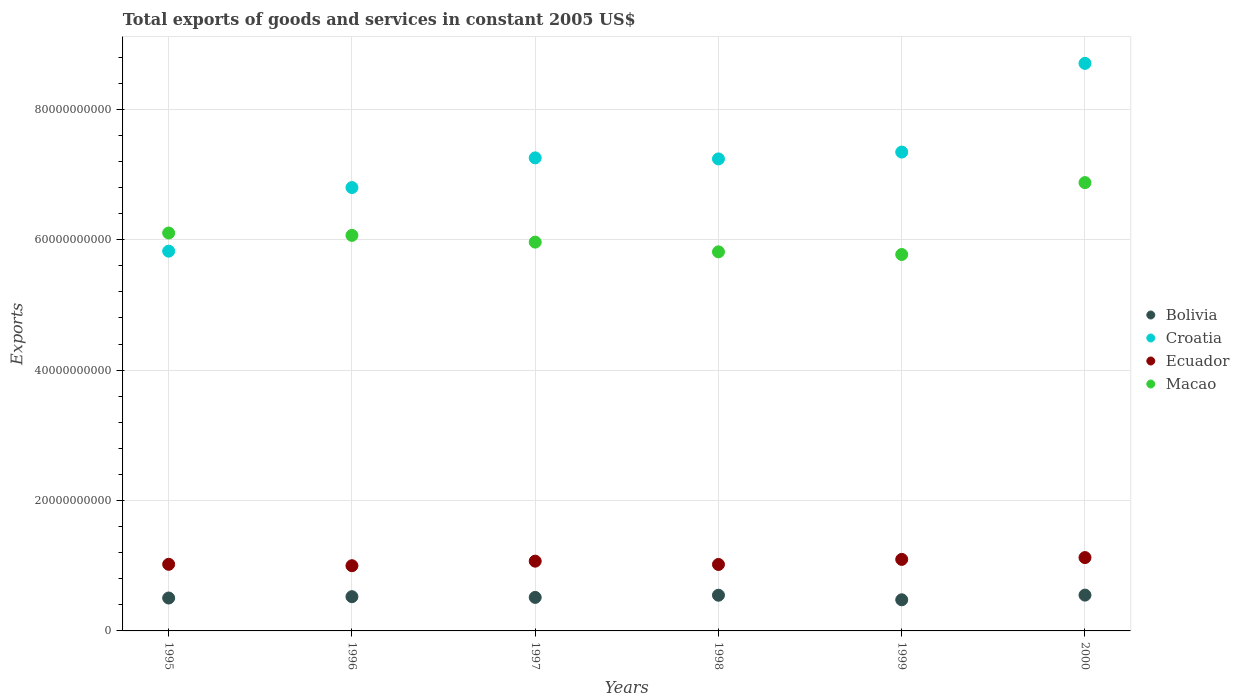How many different coloured dotlines are there?
Your response must be concise. 4. Is the number of dotlines equal to the number of legend labels?
Provide a short and direct response. Yes. What is the total exports of goods and services in Croatia in 1997?
Provide a succinct answer. 7.26e+1. Across all years, what is the maximum total exports of goods and services in Macao?
Your response must be concise. 6.88e+1. Across all years, what is the minimum total exports of goods and services in Bolivia?
Provide a succinct answer. 4.77e+09. In which year was the total exports of goods and services in Croatia minimum?
Your response must be concise. 1995. What is the total total exports of goods and services in Croatia in the graph?
Provide a short and direct response. 4.32e+11. What is the difference between the total exports of goods and services in Bolivia in 1996 and that in 1998?
Keep it short and to the point. -2.22e+08. What is the difference between the total exports of goods and services in Ecuador in 1997 and the total exports of goods and services in Bolivia in 1996?
Provide a succinct answer. 5.45e+09. What is the average total exports of goods and services in Macao per year?
Give a very brief answer. 6.10e+1. In the year 1998, what is the difference between the total exports of goods and services in Croatia and total exports of goods and services in Ecuador?
Your answer should be very brief. 6.22e+1. What is the ratio of the total exports of goods and services in Ecuador in 1996 to that in 1997?
Your answer should be compact. 0.93. Is the total exports of goods and services in Croatia in 1995 less than that in 2000?
Your answer should be very brief. Yes. Is the difference between the total exports of goods and services in Croatia in 1997 and 2000 greater than the difference between the total exports of goods and services in Ecuador in 1997 and 2000?
Keep it short and to the point. No. What is the difference between the highest and the second highest total exports of goods and services in Macao?
Ensure brevity in your answer.  7.73e+09. What is the difference between the highest and the lowest total exports of goods and services in Macao?
Your response must be concise. 1.10e+1. Is it the case that in every year, the sum of the total exports of goods and services in Croatia and total exports of goods and services in Macao  is greater than the sum of total exports of goods and services in Bolivia and total exports of goods and services in Ecuador?
Keep it short and to the point. Yes. Does the total exports of goods and services in Bolivia monotonically increase over the years?
Keep it short and to the point. No. Is the total exports of goods and services in Macao strictly less than the total exports of goods and services in Croatia over the years?
Give a very brief answer. No. How many years are there in the graph?
Give a very brief answer. 6. What is the difference between two consecutive major ticks on the Y-axis?
Provide a short and direct response. 2.00e+1. Are the values on the major ticks of Y-axis written in scientific E-notation?
Your answer should be compact. No. Does the graph contain any zero values?
Provide a succinct answer. No. Does the graph contain grids?
Your answer should be compact. Yes. How are the legend labels stacked?
Provide a succinct answer. Vertical. What is the title of the graph?
Give a very brief answer. Total exports of goods and services in constant 2005 US$. What is the label or title of the X-axis?
Your response must be concise. Years. What is the label or title of the Y-axis?
Offer a terse response. Exports. What is the Exports of Bolivia in 1995?
Make the answer very short. 5.05e+09. What is the Exports in Croatia in 1995?
Offer a terse response. 5.82e+1. What is the Exports of Ecuador in 1995?
Keep it short and to the point. 1.02e+1. What is the Exports of Macao in 1995?
Your answer should be compact. 6.10e+1. What is the Exports of Bolivia in 1996?
Provide a succinct answer. 5.25e+09. What is the Exports in Croatia in 1996?
Your answer should be compact. 6.80e+1. What is the Exports in Ecuador in 1996?
Give a very brief answer. 1.00e+1. What is the Exports of Macao in 1996?
Your answer should be compact. 6.07e+1. What is the Exports in Bolivia in 1997?
Offer a very short reply. 5.14e+09. What is the Exports in Croatia in 1997?
Your response must be concise. 7.26e+1. What is the Exports in Ecuador in 1997?
Ensure brevity in your answer.  1.07e+1. What is the Exports of Macao in 1997?
Keep it short and to the point. 5.96e+1. What is the Exports in Bolivia in 1998?
Your answer should be compact. 5.47e+09. What is the Exports of Croatia in 1998?
Keep it short and to the point. 7.24e+1. What is the Exports of Ecuador in 1998?
Offer a terse response. 1.02e+1. What is the Exports of Macao in 1998?
Keep it short and to the point. 5.81e+1. What is the Exports of Bolivia in 1999?
Keep it short and to the point. 4.77e+09. What is the Exports in Croatia in 1999?
Provide a succinct answer. 7.34e+1. What is the Exports in Ecuador in 1999?
Your response must be concise. 1.10e+1. What is the Exports of Macao in 1999?
Offer a very short reply. 5.77e+1. What is the Exports in Bolivia in 2000?
Provide a short and direct response. 5.49e+09. What is the Exports of Croatia in 2000?
Provide a short and direct response. 8.70e+1. What is the Exports of Ecuador in 2000?
Your answer should be compact. 1.12e+1. What is the Exports of Macao in 2000?
Keep it short and to the point. 6.88e+1. Across all years, what is the maximum Exports of Bolivia?
Your answer should be very brief. 5.49e+09. Across all years, what is the maximum Exports of Croatia?
Ensure brevity in your answer.  8.70e+1. Across all years, what is the maximum Exports of Ecuador?
Give a very brief answer. 1.12e+1. Across all years, what is the maximum Exports in Macao?
Offer a terse response. 6.88e+1. Across all years, what is the minimum Exports in Bolivia?
Offer a terse response. 4.77e+09. Across all years, what is the minimum Exports in Croatia?
Ensure brevity in your answer.  5.82e+1. Across all years, what is the minimum Exports of Ecuador?
Your answer should be very brief. 1.00e+1. Across all years, what is the minimum Exports of Macao?
Offer a very short reply. 5.77e+1. What is the total Exports in Bolivia in the graph?
Provide a succinct answer. 3.12e+1. What is the total Exports in Croatia in the graph?
Your response must be concise. 4.32e+11. What is the total Exports of Ecuador in the graph?
Give a very brief answer. 6.33e+1. What is the total Exports of Macao in the graph?
Your answer should be very brief. 3.66e+11. What is the difference between the Exports of Bolivia in 1995 and that in 1996?
Keep it short and to the point. -2.05e+08. What is the difference between the Exports of Croatia in 1995 and that in 1996?
Your response must be concise. -9.75e+09. What is the difference between the Exports of Ecuador in 1995 and that in 1996?
Provide a short and direct response. 2.17e+08. What is the difference between the Exports of Macao in 1995 and that in 1996?
Your answer should be very brief. 3.66e+08. What is the difference between the Exports in Bolivia in 1995 and that in 1997?
Provide a succinct answer. -9.45e+07. What is the difference between the Exports of Croatia in 1995 and that in 1997?
Make the answer very short. -1.43e+1. What is the difference between the Exports in Ecuador in 1995 and that in 1997?
Provide a short and direct response. -4.82e+08. What is the difference between the Exports of Macao in 1995 and that in 1997?
Your response must be concise. 1.40e+09. What is the difference between the Exports of Bolivia in 1995 and that in 1998?
Your answer should be very brief. -4.28e+08. What is the difference between the Exports of Croatia in 1995 and that in 1998?
Offer a very short reply. -1.41e+1. What is the difference between the Exports of Ecuador in 1995 and that in 1998?
Provide a short and direct response. 2.50e+07. What is the difference between the Exports of Macao in 1995 and that in 1998?
Your answer should be very brief. 2.89e+09. What is the difference between the Exports in Bolivia in 1995 and that in 1999?
Ensure brevity in your answer.  2.73e+08. What is the difference between the Exports of Croatia in 1995 and that in 1999?
Ensure brevity in your answer.  -1.52e+1. What is the difference between the Exports in Ecuador in 1995 and that in 1999?
Your response must be concise. -7.53e+08. What is the difference between the Exports of Macao in 1995 and that in 1999?
Make the answer very short. 3.30e+09. What is the difference between the Exports in Bolivia in 1995 and that in 2000?
Your answer should be very brief. -4.45e+08. What is the difference between the Exports of Croatia in 1995 and that in 2000?
Offer a very short reply. -2.88e+1. What is the difference between the Exports in Ecuador in 1995 and that in 2000?
Your answer should be compact. -1.03e+09. What is the difference between the Exports of Macao in 1995 and that in 2000?
Your answer should be compact. -7.73e+09. What is the difference between the Exports of Bolivia in 1996 and that in 1997?
Offer a very short reply. 1.11e+08. What is the difference between the Exports in Croatia in 1996 and that in 1997?
Your answer should be compact. -4.55e+09. What is the difference between the Exports in Ecuador in 1996 and that in 1997?
Make the answer very short. -6.99e+08. What is the difference between the Exports of Macao in 1996 and that in 1997?
Make the answer very short. 1.03e+09. What is the difference between the Exports in Bolivia in 1996 and that in 1998?
Offer a terse response. -2.22e+08. What is the difference between the Exports of Croatia in 1996 and that in 1998?
Offer a terse response. -4.40e+09. What is the difference between the Exports of Ecuador in 1996 and that in 1998?
Provide a short and direct response. -1.92e+08. What is the difference between the Exports in Macao in 1996 and that in 1998?
Ensure brevity in your answer.  2.52e+09. What is the difference between the Exports of Bolivia in 1996 and that in 1999?
Keep it short and to the point. 4.79e+08. What is the difference between the Exports in Croatia in 1996 and that in 1999?
Your response must be concise. -5.44e+09. What is the difference between the Exports in Ecuador in 1996 and that in 1999?
Make the answer very short. -9.70e+08. What is the difference between the Exports of Macao in 1996 and that in 1999?
Offer a terse response. 2.93e+09. What is the difference between the Exports of Bolivia in 1996 and that in 2000?
Provide a short and direct response. -2.39e+08. What is the difference between the Exports of Croatia in 1996 and that in 2000?
Offer a very short reply. -1.90e+1. What is the difference between the Exports of Ecuador in 1996 and that in 2000?
Offer a terse response. -1.25e+09. What is the difference between the Exports in Macao in 1996 and that in 2000?
Give a very brief answer. -8.10e+09. What is the difference between the Exports of Bolivia in 1997 and that in 1998?
Your answer should be compact. -3.33e+08. What is the difference between the Exports of Croatia in 1997 and that in 1998?
Keep it short and to the point. 1.58e+08. What is the difference between the Exports in Ecuador in 1997 and that in 1998?
Make the answer very short. 5.07e+08. What is the difference between the Exports of Macao in 1997 and that in 1998?
Your answer should be very brief. 1.49e+09. What is the difference between the Exports of Bolivia in 1997 and that in 1999?
Give a very brief answer. 3.68e+08. What is the difference between the Exports in Croatia in 1997 and that in 1999?
Your response must be concise. -8.91e+08. What is the difference between the Exports in Ecuador in 1997 and that in 1999?
Give a very brief answer. -2.71e+08. What is the difference between the Exports of Macao in 1997 and that in 1999?
Provide a short and direct response. 1.90e+09. What is the difference between the Exports of Bolivia in 1997 and that in 2000?
Offer a terse response. -3.50e+08. What is the difference between the Exports of Croatia in 1997 and that in 2000?
Provide a succinct answer. -1.45e+1. What is the difference between the Exports of Ecuador in 1997 and that in 2000?
Provide a succinct answer. -5.49e+08. What is the difference between the Exports of Macao in 1997 and that in 2000?
Give a very brief answer. -9.13e+09. What is the difference between the Exports in Bolivia in 1998 and that in 1999?
Keep it short and to the point. 7.01e+08. What is the difference between the Exports of Croatia in 1998 and that in 1999?
Your answer should be compact. -1.05e+09. What is the difference between the Exports in Ecuador in 1998 and that in 1999?
Offer a terse response. -7.78e+08. What is the difference between the Exports in Macao in 1998 and that in 1999?
Give a very brief answer. 4.07e+08. What is the difference between the Exports in Bolivia in 1998 and that in 2000?
Offer a very short reply. -1.70e+07. What is the difference between the Exports of Croatia in 1998 and that in 2000?
Offer a terse response. -1.46e+1. What is the difference between the Exports of Ecuador in 1998 and that in 2000?
Give a very brief answer. -1.06e+09. What is the difference between the Exports of Macao in 1998 and that in 2000?
Ensure brevity in your answer.  -1.06e+1. What is the difference between the Exports in Bolivia in 1999 and that in 2000?
Offer a very short reply. -7.18e+08. What is the difference between the Exports in Croatia in 1999 and that in 2000?
Provide a short and direct response. -1.36e+1. What is the difference between the Exports in Ecuador in 1999 and that in 2000?
Your answer should be very brief. -2.78e+08. What is the difference between the Exports of Macao in 1999 and that in 2000?
Give a very brief answer. -1.10e+1. What is the difference between the Exports of Bolivia in 1995 and the Exports of Croatia in 1996?
Make the answer very short. -6.30e+1. What is the difference between the Exports in Bolivia in 1995 and the Exports in Ecuador in 1996?
Give a very brief answer. -4.95e+09. What is the difference between the Exports of Bolivia in 1995 and the Exports of Macao in 1996?
Give a very brief answer. -5.56e+1. What is the difference between the Exports of Croatia in 1995 and the Exports of Ecuador in 1996?
Your answer should be very brief. 4.82e+1. What is the difference between the Exports in Croatia in 1995 and the Exports in Macao in 1996?
Offer a very short reply. -2.42e+09. What is the difference between the Exports in Ecuador in 1995 and the Exports in Macao in 1996?
Provide a succinct answer. -5.04e+1. What is the difference between the Exports in Bolivia in 1995 and the Exports in Croatia in 1997?
Ensure brevity in your answer.  -6.75e+1. What is the difference between the Exports in Bolivia in 1995 and the Exports in Ecuador in 1997?
Your response must be concise. -5.65e+09. What is the difference between the Exports in Bolivia in 1995 and the Exports in Macao in 1997?
Your response must be concise. -5.46e+1. What is the difference between the Exports of Croatia in 1995 and the Exports of Ecuador in 1997?
Give a very brief answer. 4.75e+1. What is the difference between the Exports of Croatia in 1995 and the Exports of Macao in 1997?
Make the answer very short. -1.39e+09. What is the difference between the Exports in Ecuador in 1995 and the Exports in Macao in 1997?
Provide a short and direct response. -4.94e+1. What is the difference between the Exports of Bolivia in 1995 and the Exports of Croatia in 1998?
Offer a very short reply. -6.73e+1. What is the difference between the Exports of Bolivia in 1995 and the Exports of Ecuador in 1998?
Your answer should be compact. -5.15e+09. What is the difference between the Exports in Bolivia in 1995 and the Exports in Macao in 1998?
Your answer should be compact. -5.31e+1. What is the difference between the Exports in Croatia in 1995 and the Exports in Ecuador in 1998?
Provide a short and direct response. 4.81e+1. What is the difference between the Exports of Croatia in 1995 and the Exports of Macao in 1998?
Make the answer very short. 1.05e+08. What is the difference between the Exports in Ecuador in 1995 and the Exports in Macao in 1998?
Ensure brevity in your answer.  -4.79e+1. What is the difference between the Exports in Bolivia in 1995 and the Exports in Croatia in 1999?
Offer a very short reply. -6.84e+1. What is the difference between the Exports of Bolivia in 1995 and the Exports of Ecuador in 1999?
Provide a short and direct response. -5.92e+09. What is the difference between the Exports in Bolivia in 1995 and the Exports in Macao in 1999?
Give a very brief answer. -5.27e+1. What is the difference between the Exports in Croatia in 1995 and the Exports in Ecuador in 1999?
Offer a very short reply. 4.73e+1. What is the difference between the Exports of Croatia in 1995 and the Exports of Macao in 1999?
Provide a succinct answer. 5.12e+08. What is the difference between the Exports in Ecuador in 1995 and the Exports in Macao in 1999?
Give a very brief answer. -4.75e+1. What is the difference between the Exports in Bolivia in 1995 and the Exports in Croatia in 2000?
Your response must be concise. -8.20e+1. What is the difference between the Exports in Bolivia in 1995 and the Exports in Ecuador in 2000?
Your answer should be very brief. -6.20e+09. What is the difference between the Exports in Bolivia in 1995 and the Exports in Macao in 2000?
Provide a short and direct response. -6.37e+1. What is the difference between the Exports in Croatia in 1995 and the Exports in Ecuador in 2000?
Your answer should be compact. 4.70e+1. What is the difference between the Exports in Croatia in 1995 and the Exports in Macao in 2000?
Offer a very short reply. -1.05e+1. What is the difference between the Exports of Ecuador in 1995 and the Exports of Macao in 2000?
Give a very brief answer. -5.85e+1. What is the difference between the Exports in Bolivia in 1996 and the Exports in Croatia in 1997?
Keep it short and to the point. -6.73e+1. What is the difference between the Exports in Bolivia in 1996 and the Exports in Ecuador in 1997?
Keep it short and to the point. -5.45e+09. What is the difference between the Exports in Bolivia in 1996 and the Exports in Macao in 1997?
Give a very brief answer. -5.44e+1. What is the difference between the Exports of Croatia in 1996 and the Exports of Ecuador in 1997?
Provide a short and direct response. 5.73e+1. What is the difference between the Exports in Croatia in 1996 and the Exports in Macao in 1997?
Your answer should be compact. 8.37e+09. What is the difference between the Exports of Ecuador in 1996 and the Exports of Macao in 1997?
Ensure brevity in your answer.  -4.96e+1. What is the difference between the Exports of Bolivia in 1996 and the Exports of Croatia in 1998?
Ensure brevity in your answer.  -6.71e+1. What is the difference between the Exports in Bolivia in 1996 and the Exports in Ecuador in 1998?
Your response must be concise. -4.94e+09. What is the difference between the Exports of Bolivia in 1996 and the Exports of Macao in 1998?
Ensure brevity in your answer.  -5.29e+1. What is the difference between the Exports in Croatia in 1996 and the Exports in Ecuador in 1998?
Offer a very short reply. 5.78e+1. What is the difference between the Exports of Croatia in 1996 and the Exports of Macao in 1998?
Provide a short and direct response. 9.86e+09. What is the difference between the Exports of Ecuador in 1996 and the Exports of Macao in 1998?
Offer a very short reply. -4.81e+1. What is the difference between the Exports in Bolivia in 1996 and the Exports in Croatia in 1999?
Provide a succinct answer. -6.82e+1. What is the difference between the Exports of Bolivia in 1996 and the Exports of Ecuador in 1999?
Your answer should be compact. -5.72e+09. What is the difference between the Exports in Bolivia in 1996 and the Exports in Macao in 1999?
Offer a terse response. -5.25e+1. What is the difference between the Exports of Croatia in 1996 and the Exports of Ecuador in 1999?
Offer a terse response. 5.70e+1. What is the difference between the Exports of Croatia in 1996 and the Exports of Macao in 1999?
Make the answer very short. 1.03e+1. What is the difference between the Exports in Ecuador in 1996 and the Exports in Macao in 1999?
Keep it short and to the point. -4.77e+1. What is the difference between the Exports of Bolivia in 1996 and the Exports of Croatia in 2000?
Offer a very short reply. -8.18e+1. What is the difference between the Exports of Bolivia in 1996 and the Exports of Ecuador in 2000?
Your response must be concise. -6.00e+09. What is the difference between the Exports of Bolivia in 1996 and the Exports of Macao in 2000?
Provide a succinct answer. -6.35e+1. What is the difference between the Exports of Croatia in 1996 and the Exports of Ecuador in 2000?
Offer a terse response. 5.68e+1. What is the difference between the Exports of Croatia in 1996 and the Exports of Macao in 2000?
Your answer should be compact. -7.61e+08. What is the difference between the Exports in Ecuador in 1996 and the Exports in Macao in 2000?
Provide a short and direct response. -5.88e+1. What is the difference between the Exports of Bolivia in 1997 and the Exports of Croatia in 1998?
Offer a very short reply. -6.73e+1. What is the difference between the Exports of Bolivia in 1997 and the Exports of Ecuador in 1998?
Keep it short and to the point. -5.05e+09. What is the difference between the Exports in Bolivia in 1997 and the Exports in Macao in 1998?
Provide a succinct answer. -5.30e+1. What is the difference between the Exports in Croatia in 1997 and the Exports in Ecuador in 1998?
Provide a short and direct response. 6.24e+1. What is the difference between the Exports in Croatia in 1997 and the Exports in Macao in 1998?
Give a very brief answer. 1.44e+1. What is the difference between the Exports of Ecuador in 1997 and the Exports of Macao in 1998?
Provide a succinct answer. -4.74e+1. What is the difference between the Exports of Bolivia in 1997 and the Exports of Croatia in 1999?
Provide a succinct answer. -6.83e+1. What is the difference between the Exports of Bolivia in 1997 and the Exports of Ecuador in 1999?
Provide a short and direct response. -5.83e+09. What is the difference between the Exports of Bolivia in 1997 and the Exports of Macao in 1999?
Ensure brevity in your answer.  -5.26e+1. What is the difference between the Exports of Croatia in 1997 and the Exports of Ecuador in 1999?
Offer a terse response. 6.16e+1. What is the difference between the Exports in Croatia in 1997 and the Exports in Macao in 1999?
Make the answer very short. 1.48e+1. What is the difference between the Exports of Ecuador in 1997 and the Exports of Macao in 1999?
Offer a terse response. -4.70e+1. What is the difference between the Exports in Bolivia in 1997 and the Exports in Croatia in 2000?
Your response must be concise. -8.19e+1. What is the difference between the Exports of Bolivia in 1997 and the Exports of Ecuador in 2000?
Provide a short and direct response. -6.11e+09. What is the difference between the Exports in Bolivia in 1997 and the Exports in Macao in 2000?
Your response must be concise. -6.36e+1. What is the difference between the Exports of Croatia in 1997 and the Exports of Ecuador in 2000?
Make the answer very short. 6.13e+1. What is the difference between the Exports in Croatia in 1997 and the Exports in Macao in 2000?
Offer a very short reply. 3.79e+09. What is the difference between the Exports of Ecuador in 1997 and the Exports of Macao in 2000?
Make the answer very short. -5.81e+1. What is the difference between the Exports of Bolivia in 1998 and the Exports of Croatia in 1999?
Make the answer very short. -6.80e+1. What is the difference between the Exports in Bolivia in 1998 and the Exports in Ecuador in 1999?
Make the answer very short. -5.50e+09. What is the difference between the Exports of Bolivia in 1998 and the Exports of Macao in 1999?
Keep it short and to the point. -5.23e+1. What is the difference between the Exports of Croatia in 1998 and the Exports of Ecuador in 1999?
Your response must be concise. 6.14e+1. What is the difference between the Exports in Croatia in 1998 and the Exports in Macao in 1999?
Your response must be concise. 1.47e+1. What is the difference between the Exports in Ecuador in 1998 and the Exports in Macao in 1999?
Your answer should be very brief. -4.75e+1. What is the difference between the Exports of Bolivia in 1998 and the Exports of Croatia in 2000?
Give a very brief answer. -8.16e+1. What is the difference between the Exports of Bolivia in 1998 and the Exports of Ecuador in 2000?
Your answer should be very brief. -5.77e+09. What is the difference between the Exports in Bolivia in 1998 and the Exports in Macao in 2000?
Make the answer very short. -6.33e+1. What is the difference between the Exports of Croatia in 1998 and the Exports of Ecuador in 2000?
Your answer should be compact. 6.11e+1. What is the difference between the Exports in Croatia in 1998 and the Exports in Macao in 2000?
Your response must be concise. 3.63e+09. What is the difference between the Exports in Ecuador in 1998 and the Exports in Macao in 2000?
Provide a short and direct response. -5.86e+1. What is the difference between the Exports of Bolivia in 1999 and the Exports of Croatia in 2000?
Offer a very short reply. -8.23e+1. What is the difference between the Exports in Bolivia in 1999 and the Exports in Ecuador in 2000?
Provide a short and direct response. -6.47e+09. What is the difference between the Exports in Bolivia in 1999 and the Exports in Macao in 2000?
Ensure brevity in your answer.  -6.40e+1. What is the difference between the Exports of Croatia in 1999 and the Exports of Ecuador in 2000?
Ensure brevity in your answer.  6.22e+1. What is the difference between the Exports in Croatia in 1999 and the Exports in Macao in 2000?
Your answer should be compact. 4.68e+09. What is the difference between the Exports of Ecuador in 1999 and the Exports of Macao in 2000?
Your answer should be compact. -5.78e+1. What is the average Exports in Bolivia per year?
Your answer should be very brief. 5.20e+09. What is the average Exports of Croatia per year?
Make the answer very short. 7.19e+1. What is the average Exports in Ecuador per year?
Your answer should be very brief. 1.06e+1. What is the average Exports in Macao per year?
Offer a very short reply. 6.10e+1. In the year 1995, what is the difference between the Exports in Bolivia and Exports in Croatia?
Offer a very short reply. -5.32e+1. In the year 1995, what is the difference between the Exports of Bolivia and Exports of Ecuador?
Your answer should be very brief. -5.17e+09. In the year 1995, what is the difference between the Exports in Bolivia and Exports in Macao?
Offer a terse response. -5.60e+1. In the year 1995, what is the difference between the Exports of Croatia and Exports of Ecuador?
Provide a succinct answer. 4.80e+1. In the year 1995, what is the difference between the Exports in Croatia and Exports in Macao?
Provide a succinct answer. -2.78e+09. In the year 1995, what is the difference between the Exports of Ecuador and Exports of Macao?
Offer a very short reply. -5.08e+1. In the year 1996, what is the difference between the Exports in Bolivia and Exports in Croatia?
Provide a succinct answer. -6.27e+1. In the year 1996, what is the difference between the Exports of Bolivia and Exports of Ecuador?
Give a very brief answer. -4.75e+09. In the year 1996, what is the difference between the Exports in Bolivia and Exports in Macao?
Provide a short and direct response. -5.54e+1. In the year 1996, what is the difference between the Exports in Croatia and Exports in Ecuador?
Your answer should be compact. 5.80e+1. In the year 1996, what is the difference between the Exports in Croatia and Exports in Macao?
Provide a succinct answer. 7.34e+09. In the year 1996, what is the difference between the Exports in Ecuador and Exports in Macao?
Give a very brief answer. -5.07e+1. In the year 1997, what is the difference between the Exports in Bolivia and Exports in Croatia?
Offer a very short reply. -6.74e+1. In the year 1997, what is the difference between the Exports in Bolivia and Exports in Ecuador?
Offer a terse response. -5.56e+09. In the year 1997, what is the difference between the Exports in Bolivia and Exports in Macao?
Provide a succinct answer. -5.45e+1. In the year 1997, what is the difference between the Exports of Croatia and Exports of Ecuador?
Ensure brevity in your answer.  6.19e+1. In the year 1997, what is the difference between the Exports of Croatia and Exports of Macao?
Make the answer very short. 1.29e+1. In the year 1997, what is the difference between the Exports in Ecuador and Exports in Macao?
Ensure brevity in your answer.  -4.89e+1. In the year 1998, what is the difference between the Exports in Bolivia and Exports in Croatia?
Your answer should be compact. -6.69e+1. In the year 1998, what is the difference between the Exports of Bolivia and Exports of Ecuador?
Provide a short and direct response. -4.72e+09. In the year 1998, what is the difference between the Exports in Bolivia and Exports in Macao?
Your answer should be very brief. -5.27e+1. In the year 1998, what is the difference between the Exports in Croatia and Exports in Ecuador?
Keep it short and to the point. 6.22e+1. In the year 1998, what is the difference between the Exports of Croatia and Exports of Macao?
Offer a terse response. 1.43e+1. In the year 1998, what is the difference between the Exports of Ecuador and Exports of Macao?
Ensure brevity in your answer.  -4.79e+1. In the year 1999, what is the difference between the Exports in Bolivia and Exports in Croatia?
Provide a short and direct response. -6.87e+1. In the year 1999, what is the difference between the Exports in Bolivia and Exports in Ecuador?
Ensure brevity in your answer.  -6.20e+09. In the year 1999, what is the difference between the Exports of Bolivia and Exports of Macao?
Offer a terse response. -5.30e+1. In the year 1999, what is the difference between the Exports of Croatia and Exports of Ecuador?
Your response must be concise. 6.25e+1. In the year 1999, what is the difference between the Exports of Croatia and Exports of Macao?
Provide a short and direct response. 1.57e+1. In the year 1999, what is the difference between the Exports in Ecuador and Exports in Macao?
Your answer should be compact. -4.68e+1. In the year 2000, what is the difference between the Exports of Bolivia and Exports of Croatia?
Give a very brief answer. -8.16e+1. In the year 2000, what is the difference between the Exports in Bolivia and Exports in Ecuador?
Make the answer very short. -5.76e+09. In the year 2000, what is the difference between the Exports of Bolivia and Exports of Macao?
Provide a short and direct response. -6.33e+1. In the year 2000, what is the difference between the Exports in Croatia and Exports in Ecuador?
Provide a short and direct response. 7.58e+1. In the year 2000, what is the difference between the Exports of Croatia and Exports of Macao?
Your response must be concise. 1.83e+1. In the year 2000, what is the difference between the Exports of Ecuador and Exports of Macao?
Keep it short and to the point. -5.75e+1. What is the ratio of the Exports in Bolivia in 1995 to that in 1996?
Keep it short and to the point. 0.96. What is the ratio of the Exports of Croatia in 1995 to that in 1996?
Keep it short and to the point. 0.86. What is the ratio of the Exports of Ecuador in 1995 to that in 1996?
Provide a short and direct response. 1.02. What is the ratio of the Exports in Bolivia in 1995 to that in 1997?
Your response must be concise. 0.98. What is the ratio of the Exports in Croatia in 1995 to that in 1997?
Provide a succinct answer. 0.8. What is the ratio of the Exports in Ecuador in 1995 to that in 1997?
Provide a succinct answer. 0.95. What is the ratio of the Exports of Macao in 1995 to that in 1997?
Ensure brevity in your answer.  1.02. What is the ratio of the Exports of Bolivia in 1995 to that in 1998?
Offer a terse response. 0.92. What is the ratio of the Exports in Croatia in 1995 to that in 1998?
Offer a very short reply. 0.8. What is the ratio of the Exports of Macao in 1995 to that in 1998?
Provide a short and direct response. 1.05. What is the ratio of the Exports in Bolivia in 1995 to that in 1999?
Give a very brief answer. 1.06. What is the ratio of the Exports in Croatia in 1995 to that in 1999?
Offer a terse response. 0.79. What is the ratio of the Exports of Ecuador in 1995 to that in 1999?
Ensure brevity in your answer.  0.93. What is the ratio of the Exports of Macao in 1995 to that in 1999?
Ensure brevity in your answer.  1.06. What is the ratio of the Exports of Bolivia in 1995 to that in 2000?
Your answer should be very brief. 0.92. What is the ratio of the Exports of Croatia in 1995 to that in 2000?
Your answer should be compact. 0.67. What is the ratio of the Exports in Ecuador in 1995 to that in 2000?
Make the answer very short. 0.91. What is the ratio of the Exports of Macao in 1995 to that in 2000?
Offer a very short reply. 0.89. What is the ratio of the Exports of Bolivia in 1996 to that in 1997?
Your answer should be very brief. 1.02. What is the ratio of the Exports of Croatia in 1996 to that in 1997?
Offer a terse response. 0.94. What is the ratio of the Exports of Ecuador in 1996 to that in 1997?
Provide a succinct answer. 0.93. What is the ratio of the Exports in Macao in 1996 to that in 1997?
Make the answer very short. 1.02. What is the ratio of the Exports of Bolivia in 1996 to that in 1998?
Offer a very short reply. 0.96. What is the ratio of the Exports of Croatia in 1996 to that in 1998?
Offer a very short reply. 0.94. What is the ratio of the Exports in Ecuador in 1996 to that in 1998?
Provide a succinct answer. 0.98. What is the ratio of the Exports of Macao in 1996 to that in 1998?
Provide a succinct answer. 1.04. What is the ratio of the Exports in Bolivia in 1996 to that in 1999?
Make the answer very short. 1.1. What is the ratio of the Exports in Croatia in 1996 to that in 1999?
Provide a short and direct response. 0.93. What is the ratio of the Exports of Ecuador in 1996 to that in 1999?
Ensure brevity in your answer.  0.91. What is the ratio of the Exports of Macao in 1996 to that in 1999?
Your answer should be compact. 1.05. What is the ratio of the Exports of Bolivia in 1996 to that in 2000?
Offer a very short reply. 0.96. What is the ratio of the Exports in Croatia in 1996 to that in 2000?
Provide a succinct answer. 0.78. What is the ratio of the Exports of Ecuador in 1996 to that in 2000?
Ensure brevity in your answer.  0.89. What is the ratio of the Exports of Macao in 1996 to that in 2000?
Your answer should be compact. 0.88. What is the ratio of the Exports in Bolivia in 1997 to that in 1998?
Offer a terse response. 0.94. What is the ratio of the Exports in Croatia in 1997 to that in 1998?
Your response must be concise. 1. What is the ratio of the Exports in Ecuador in 1997 to that in 1998?
Give a very brief answer. 1.05. What is the ratio of the Exports of Macao in 1997 to that in 1998?
Offer a terse response. 1.03. What is the ratio of the Exports of Bolivia in 1997 to that in 1999?
Offer a very short reply. 1.08. What is the ratio of the Exports of Croatia in 1997 to that in 1999?
Ensure brevity in your answer.  0.99. What is the ratio of the Exports in Ecuador in 1997 to that in 1999?
Ensure brevity in your answer.  0.98. What is the ratio of the Exports in Macao in 1997 to that in 1999?
Provide a short and direct response. 1.03. What is the ratio of the Exports of Bolivia in 1997 to that in 2000?
Keep it short and to the point. 0.94. What is the ratio of the Exports in Croatia in 1997 to that in 2000?
Provide a short and direct response. 0.83. What is the ratio of the Exports in Ecuador in 1997 to that in 2000?
Offer a terse response. 0.95. What is the ratio of the Exports of Macao in 1997 to that in 2000?
Your answer should be very brief. 0.87. What is the ratio of the Exports in Bolivia in 1998 to that in 1999?
Your answer should be compact. 1.15. What is the ratio of the Exports in Croatia in 1998 to that in 1999?
Your response must be concise. 0.99. What is the ratio of the Exports in Ecuador in 1998 to that in 1999?
Make the answer very short. 0.93. What is the ratio of the Exports of Macao in 1998 to that in 1999?
Your answer should be very brief. 1.01. What is the ratio of the Exports of Bolivia in 1998 to that in 2000?
Ensure brevity in your answer.  1. What is the ratio of the Exports in Croatia in 1998 to that in 2000?
Your answer should be very brief. 0.83. What is the ratio of the Exports in Ecuador in 1998 to that in 2000?
Keep it short and to the point. 0.91. What is the ratio of the Exports of Macao in 1998 to that in 2000?
Make the answer very short. 0.85. What is the ratio of the Exports in Bolivia in 1999 to that in 2000?
Keep it short and to the point. 0.87. What is the ratio of the Exports of Croatia in 1999 to that in 2000?
Offer a terse response. 0.84. What is the ratio of the Exports in Ecuador in 1999 to that in 2000?
Offer a terse response. 0.98. What is the ratio of the Exports of Macao in 1999 to that in 2000?
Offer a terse response. 0.84. What is the difference between the highest and the second highest Exports of Bolivia?
Your answer should be compact. 1.70e+07. What is the difference between the highest and the second highest Exports of Croatia?
Your answer should be very brief. 1.36e+1. What is the difference between the highest and the second highest Exports of Ecuador?
Offer a very short reply. 2.78e+08. What is the difference between the highest and the second highest Exports in Macao?
Offer a very short reply. 7.73e+09. What is the difference between the highest and the lowest Exports in Bolivia?
Make the answer very short. 7.18e+08. What is the difference between the highest and the lowest Exports of Croatia?
Ensure brevity in your answer.  2.88e+1. What is the difference between the highest and the lowest Exports in Ecuador?
Your answer should be very brief. 1.25e+09. What is the difference between the highest and the lowest Exports in Macao?
Offer a very short reply. 1.10e+1. 